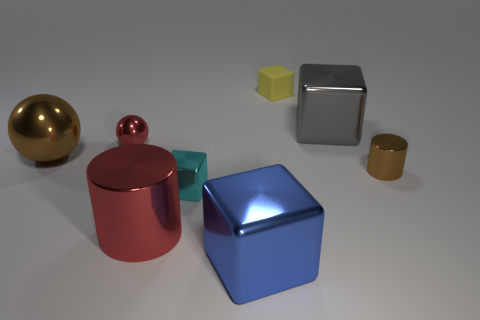Is there any other thing that is the same material as the small yellow object?
Your response must be concise. No. There is a sphere that is the same color as the small shiny cylinder; what is its size?
Offer a very short reply. Large. How many things are tiny yellow metallic spheres or gray cubes?
Provide a succinct answer. 1. There is a shiny cylinder that is the same size as the red metallic ball; what color is it?
Your answer should be very brief. Brown. There is a blue thing; is its shape the same as the object that is behind the gray object?
Offer a terse response. Yes. What number of objects are either small objects to the left of the large gray cube or large blue metallic cubes that are to the left of the tiny yellow object?
Offer a terse response. 4. There is a metallic object that is the same color as the small metal ball; what is its shape?
Your answer should be compact. Cylinder. There is a small yellow matte object on the left side of the small brown thing; what shape is it?
Offer a terse response. Cube. There is a metal thing that is right of the gray shiny object; does it have the same shape as the large red thing?
Offer a terse response. Yes. How many objects are small objects that are in front of the brown shiny ball or tiny yellow matte blocks?
Keep it short and to the point. 3. 